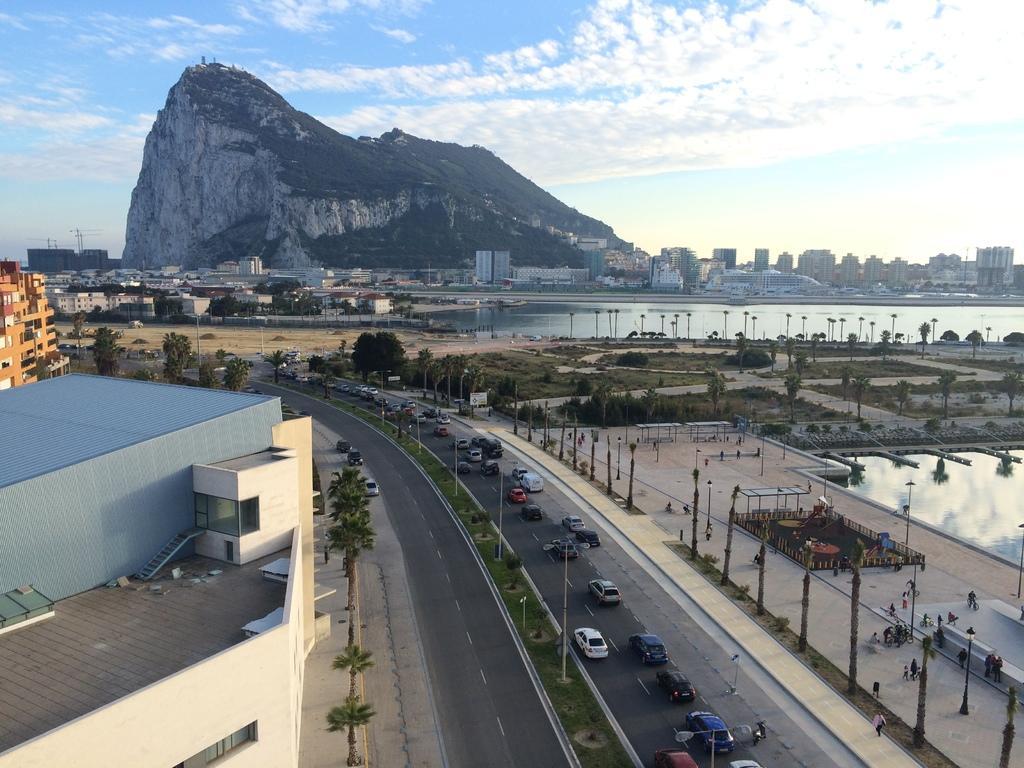Could you give a brief overview of what you see in this image? There is a two way road, which is having divider, on which, there are poles, grass on the ground and there are plants. On the right side road, there are vehicles. On the left side, there are buildings, near footpath, on which, there are trees. On the right side, there are trees on the ground, near a footpath, there is a water pond, there is a garden, there are buildings, there is hill and there are clouds in the blue sky. 